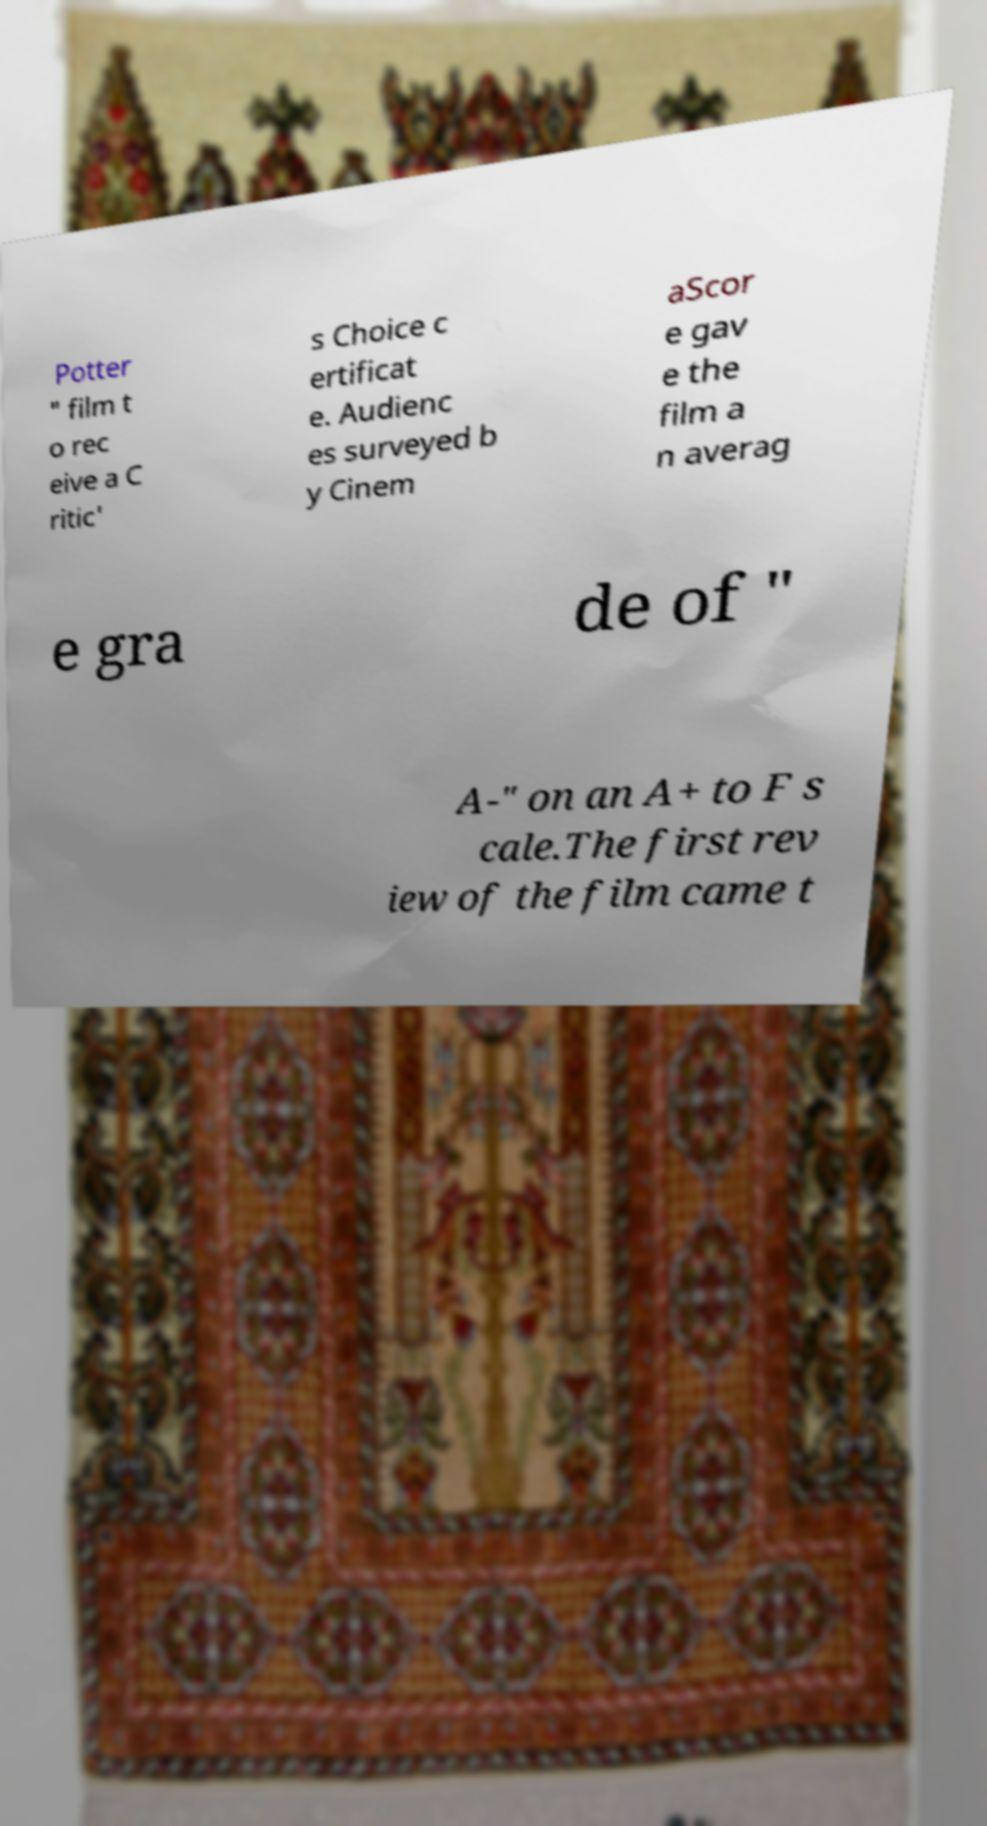I need the written content from this picture converted into text. Can you do that? Potter " film t o rec eive a C ritic' s Choice c ertificat e. Audienc es surveyed b y Cinem aScor e gav e the film a n averag e gra de of " A-" on an A+ to F s cale.The first rev iew of the film came t 